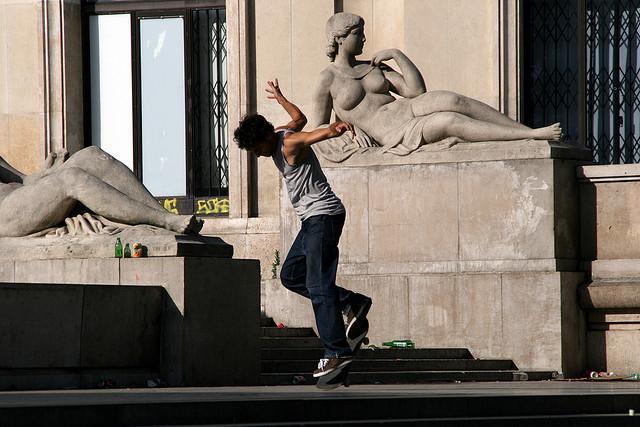How many breasts?
Give a very brief answer. 2. How many people can you see?
Give a very brief answer. 1. 